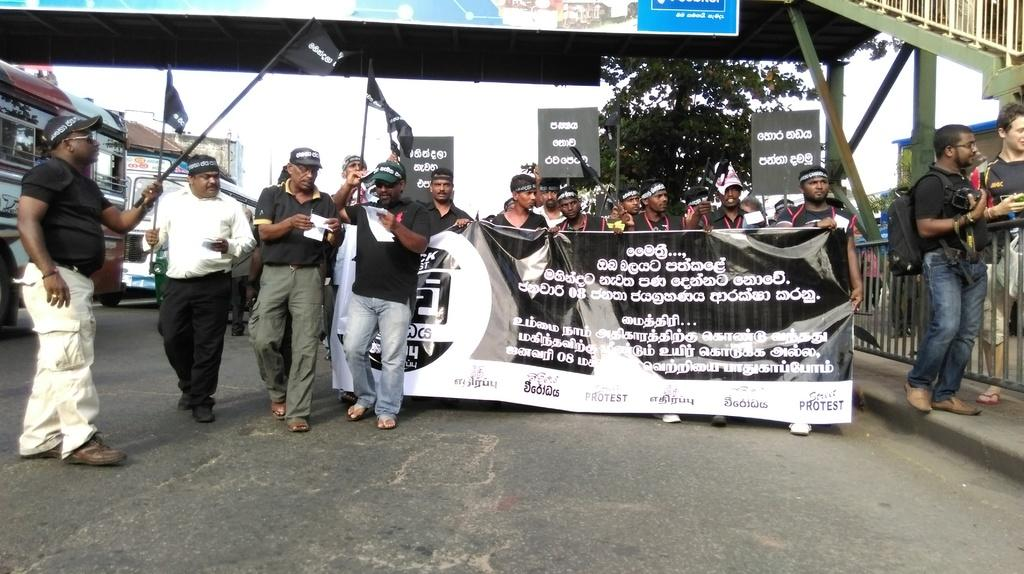What are the people in the image doing? The people in the image are walking on the road. What are the people holding while walking on the road? The people are holding boards. What else can be seen on the road in the image? There are vehicles moving on the road in the image. What type of straw is being used to make the money in the image? There is no straw or money present in the image; it features people walking on the road while holding boards. 